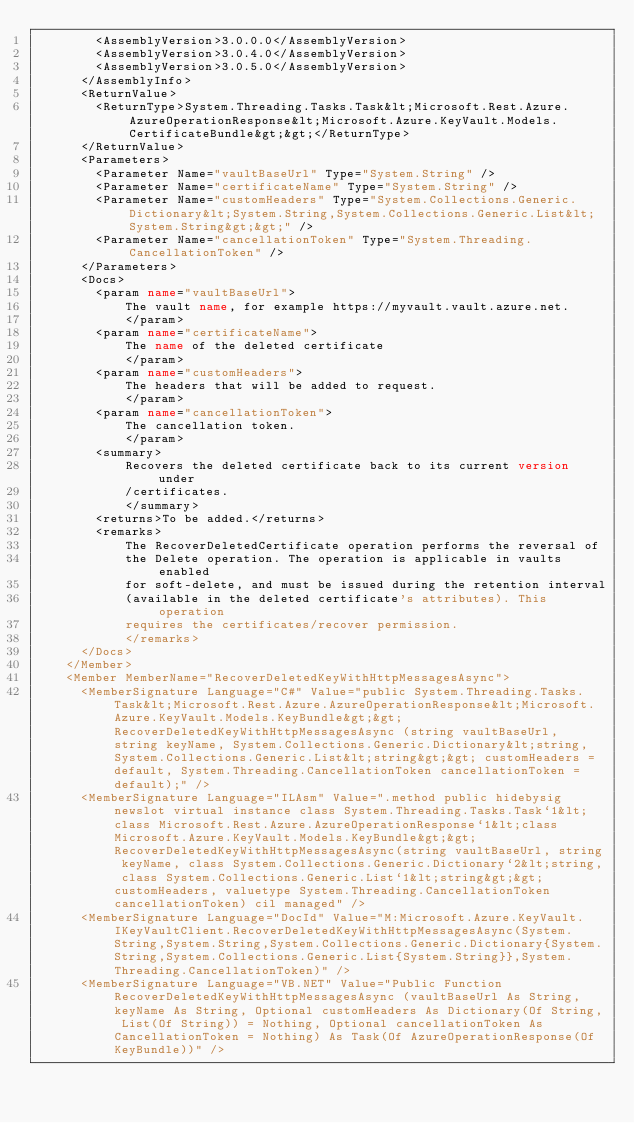Convert code to text. <code><loc_0><loc_0><loc_500><loc_500><_XML_>        <AssemblyVersion>3.0.0.0</AssemblyVersion>
        <AssemblyVersion>3.0.4.0</AssemblyVersion>
        <AssemblyVersion>3.0.5.0</AssemblyVersion>
      </AssemblyInfo>
      <ReturnValue>
        <ReturnType>System.Threading.Tasks.Task&lt;Microsoft.Rest.Azure.AzureOperationResponse&lt;Microsoft.Azure.KeyVault.Models.CertificateBundle&gt;&gt;</ReturnType>
      </ReturnValue>
      <Parameters>
        <Parameter Name="vaultBaseUrl" Type="System.String" />
        <Parameter Name="certificateName" Type="System.String" />
        <Parameter Name="customHeaders" Type="System.Collections.Generic.Dictionary&lt;System.String,System.Collections.Generic.List&lt;System.String&gt;&gt;" />
        <Parameter Name="cancellationToken" Type="System.Threading.CancellationToken" />
      </Parameters>
      <Docs>
        <param name="vaultBaseUrl">
            The vault name, for example https://myvault.vault.azure.net.
            </param>
        <param name="certificateName">
            The name of the deleted certificate
            </param>
        <param name="customHeaders">
            The headers that will be added to request.
            </param>
        <param name="cancellationToken">
            The cancellation token.
            </param>
        <summary>
            Recovers the deleted certificate back to its current version under
            /certificates.
            </summary>
        <returns>To be added.</returns>
        <remarks>
            The RecoverDeletedCertificate operation performs the reversal of
            the Delete operation. The operation is applicable in vaults enabled
            for soft-delete, and must be issued during the retention interval
            (available in the deleted certificate's attributes). This operation
            requires the certificates/recover permission.
            </remarks>
      </Docs>
    </Member>
    <Member MemberName="RecoverDeletedKeyWithHttpMessagesAsync">
      <MemberSignature Language="C#" Value="public System.Threading.Tasks.Task&lt;Microsoft.Rest.Azure.AzureOperationResponse&lt;Microsoft.Azure.KeyVault.Models.KeyBundle&gt;&gt; RecoverDeletedKeyWithHttpMessagesAsync (string vaultBaseUrl, string keyName, System.Collections.Generic.Dictionary&lt;string,System.Collections.Generic.List&lt;string&gt;&gt; customHeaders = default, System.Threading.CancellationToken cancellationToken = default);" />
      <MemberSignature Language="ILAsm" Value=".method public hidebysig newslot virtual instance class System.Threading.Tasks.Task`1&lt;class Microsoft.Rest.Azure.AzureOperationResponse`1&lt;class Microsoft.Azure.KeyVault.Models.KeyBundle&gt;&gt; RecoverDeletedKeyWithHttpMessagesAsync(string vaultBaseUrl, string keyName, class System.Collections.Generic.Dictionary`2&lt;string, class System.Collections.Generic.List`1&lt;string&gt;&gt; customHeaders, valuetype System.Threading.CancellationToken cancellationToken) cil managed" />
      <MemberSignature Language="DocId" Value="M:Microsoft.Azure.KeyVault.IKeyVaultClient.RecoverDeletedKeyWithHttpMessagesAsync(System.String,System.String,System.Collections.Generic.Dictionary{System.String,System.Collections.Generic.List{System.String}},System.Threading.CancellationToken)" />
      <MemberSignature Language="VB.NET" Value="Public Function RecoverDeletedKeyWithHttpMessagesAsync (vaultBaseUrl As String, keyName As String, Optional customHeaders As Dictionary(Of String, List(Of String)) = Nothing, Optional cancellationToken As CancellationToken = Nothing) As Task(Of AzureOperationResponse(Of KeyBundle))" /></code> 